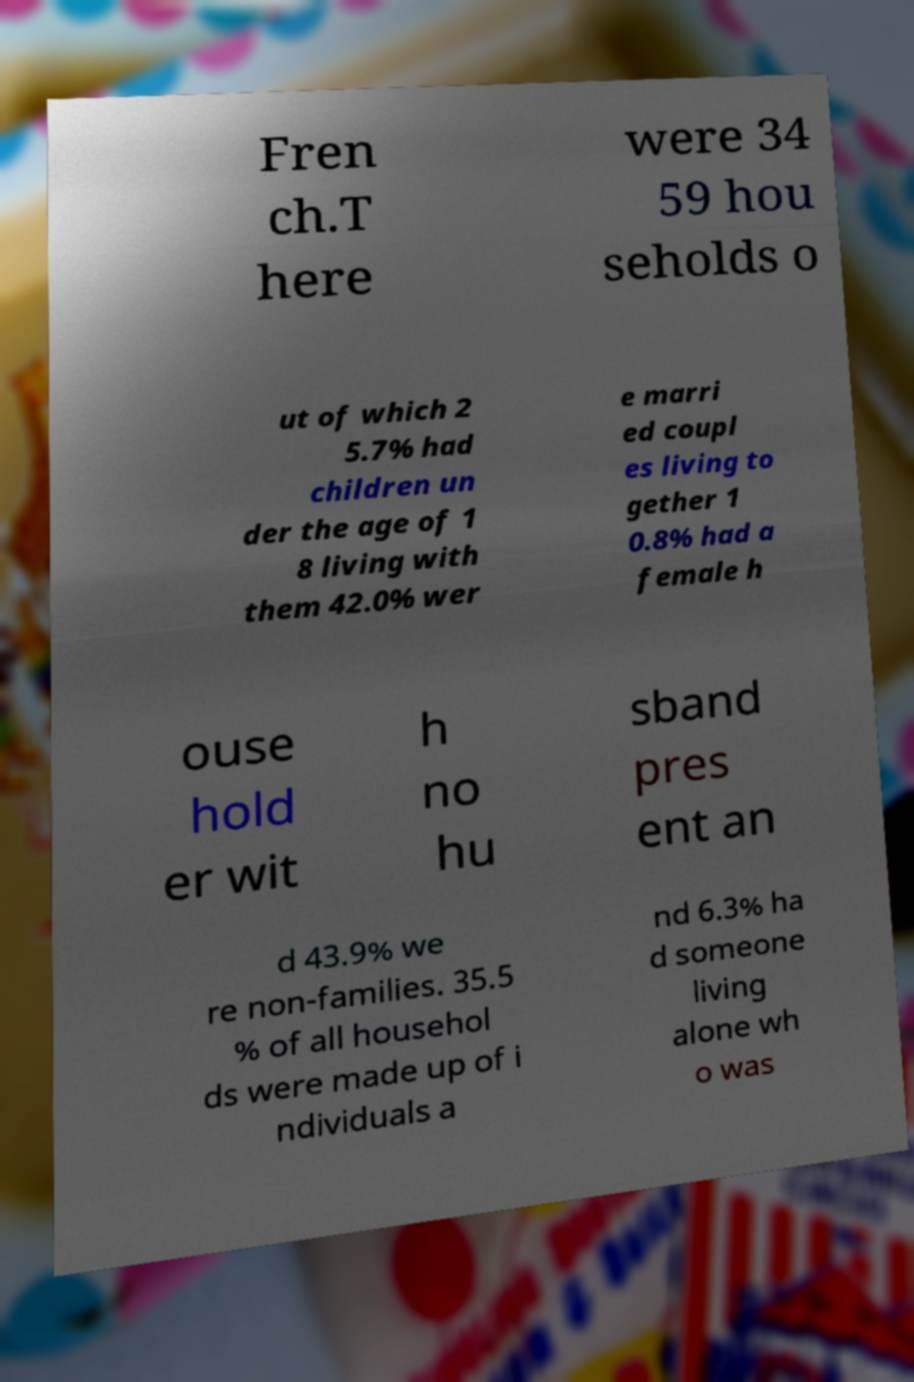Can you read and provide the text displayed in the image?This photo seems to have some interesting text. Can you extract and type it out for me? Fren ch.T here were 34 59 hou seholds o ut of which 2 5.7% had children un der the age of 1 8 living with them 42.0% wer e marri ed coupl es living to gether 1 0.8% had a female h ouse hold er wit h no hu sband pres ent an d 43.9% we re non-families. 35.5 % of all househol ds were made up of i ndividuals a nd 6.3% ha d someone living alone wh o was 